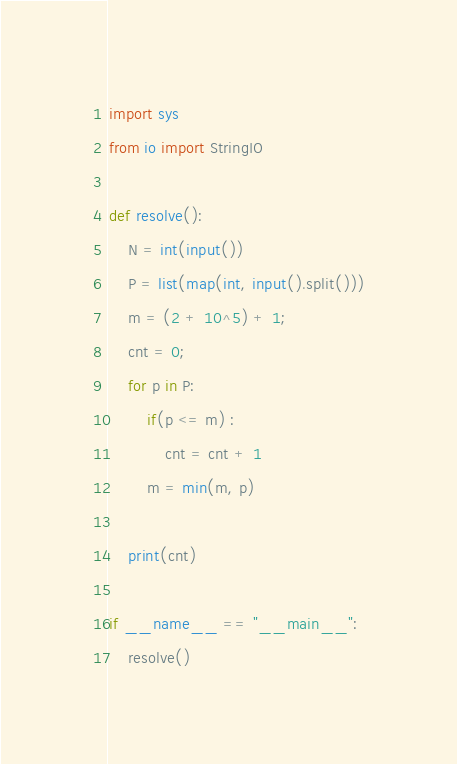<code> <loc_0><loc_0><loc_500><loc_500><_Python_>import sys
from io import StringIO

def resolve():
    N = int(input())
    P = list(map(int, input().split()))
    m = (2 + 10^5) + 1;
    cnt = 0;
    for p in P:
        if(p <= m) :
            cnt = cnt + 1
        m = min(m, p)

    print(cnt)

if __name__ == "__main__":
    resolve()</code> 